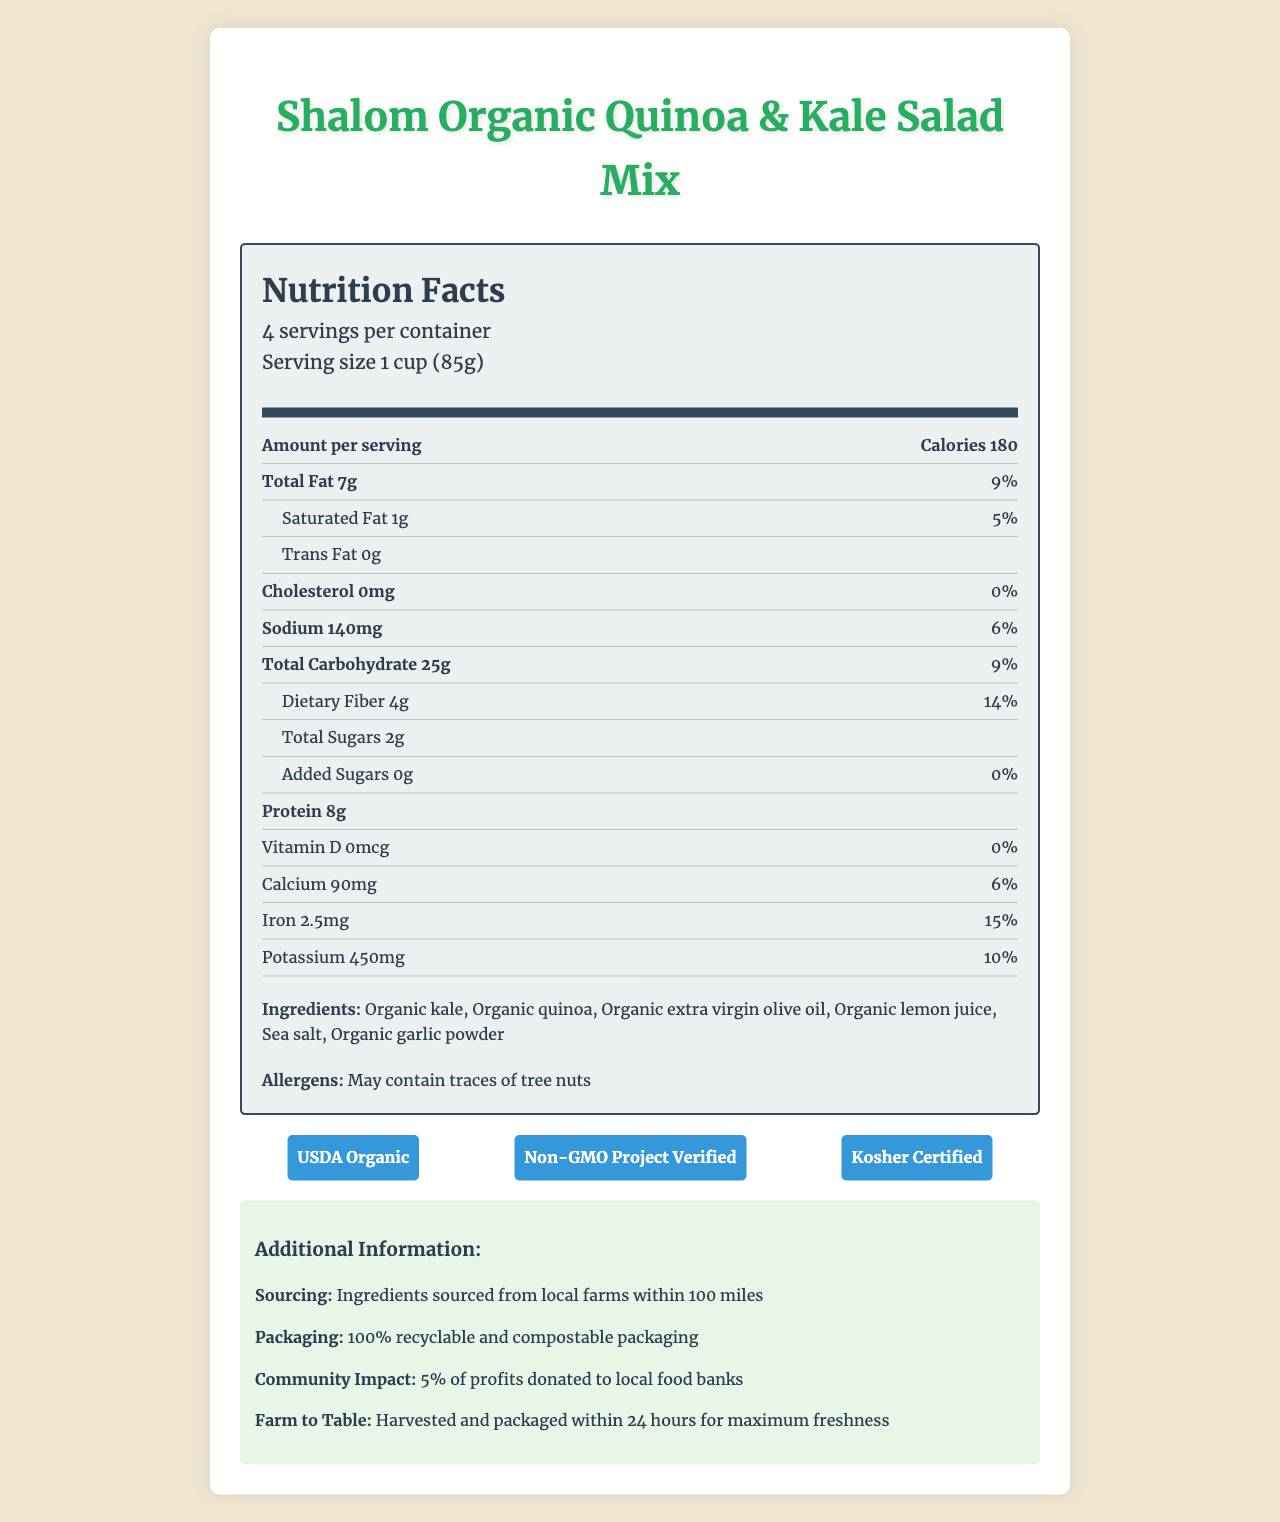what is the size of each serving? The serving size information is provided near the top of the nutrition label.
Answer: 1 cup (85g) how many calories are in each serving? The calorie count per serving is listed in the "Amount per serving" section.
Answer: 180 what is the total fat content per serving? The total fat content per serving is given in the nutrient details.
Answer: 7g how much dietary fiber does each serving contain? The dietary fiber amount per serving is stated under the "Total Carbohydrate" section.
Answer: 4g how many servings are in the container? The number of servings per container is stated in the serving information.
Answer: 4 what percentage of the daily value of iron does one serving provide? The daily value percentage for iron is listed in the nutrient breakdown.
Answer: 15% is there any cholesterol in this product? The cholesterol amount is listed as 0mg in the nutrient details.
Answer: No is this product suitable for someone with a tree nut allergy? The allergen information states that it may contain traces of tree nuts.
Answer: No how much protein is in a single serving of this salad mix? The protein content per serving is given in the nutrient list.
Answer: 8g where are the ingredients sourced from? The additional information section notes that ingredients are sourced from local farms within 100 miles.
Answer: Local farms within 100 miles what certifications does this product have? The certifications are displayed in the certifications section with corresponding labels.
Answer: USDA Organic, Non-GMO Project Verified, Kosher Certified how many grams of added sugars are in this product? The amount of added sugars per serving is specified in the nutrient details.
Answer: 0g what is the main difference between total sugars and added sugars in this product? The total sugars amount is given, and the added sugars are separately listed as 0g.
Answer: Total sugars include naturally occurring sugars, while added sugars are specifically those added during processing. This product has 2g total sugars and 0g added sugars. what community benefit does purchasing this product provide? The additional information mentions that 5% of profits are donated to local food banks.
Answer: 5% of profits donated to local food banks which of the following is not an ingredient in the salad mix? A. Organic kale B. Organic quinoa C. Organic apple cider vinegar The ingredient list does not include organic apple cider vinegar.
Answer: C how much calcium does one serving provide in terms of daily value? A. 3% B. 6% C. 9% The calcium daily value percentage per serving is listed as 6%.
Answer: B is this product locally sourced? The additional information confirms that the ingredients are sourced from local farms within 100 miles.
Answer: Yes how is the packaging of this product described? The packaging information states that it is fully recyclable and compostable.
Answer: 100% recyclable and compostable can you determine the total amount of sodium in the entire container? The sodium amount per serving is given, but total sodium for the entire container isn't directly provided and requires calculation.
Answer: Not enough information summarize the main information presented in the document. The summary covers the main elements such as nutrient details, certifications, ingredients, sourcing, and community impact.
Answer: The document is a nutrition facts label for the Shalom Organic Quinoa & Kale Salad Mix. It provides detailed nutritional information, including serving size, calories, and various nutrient amounts. It lists ingredients and allergen warnings, along with several certifications and additional information like local sourcing and community impact. 